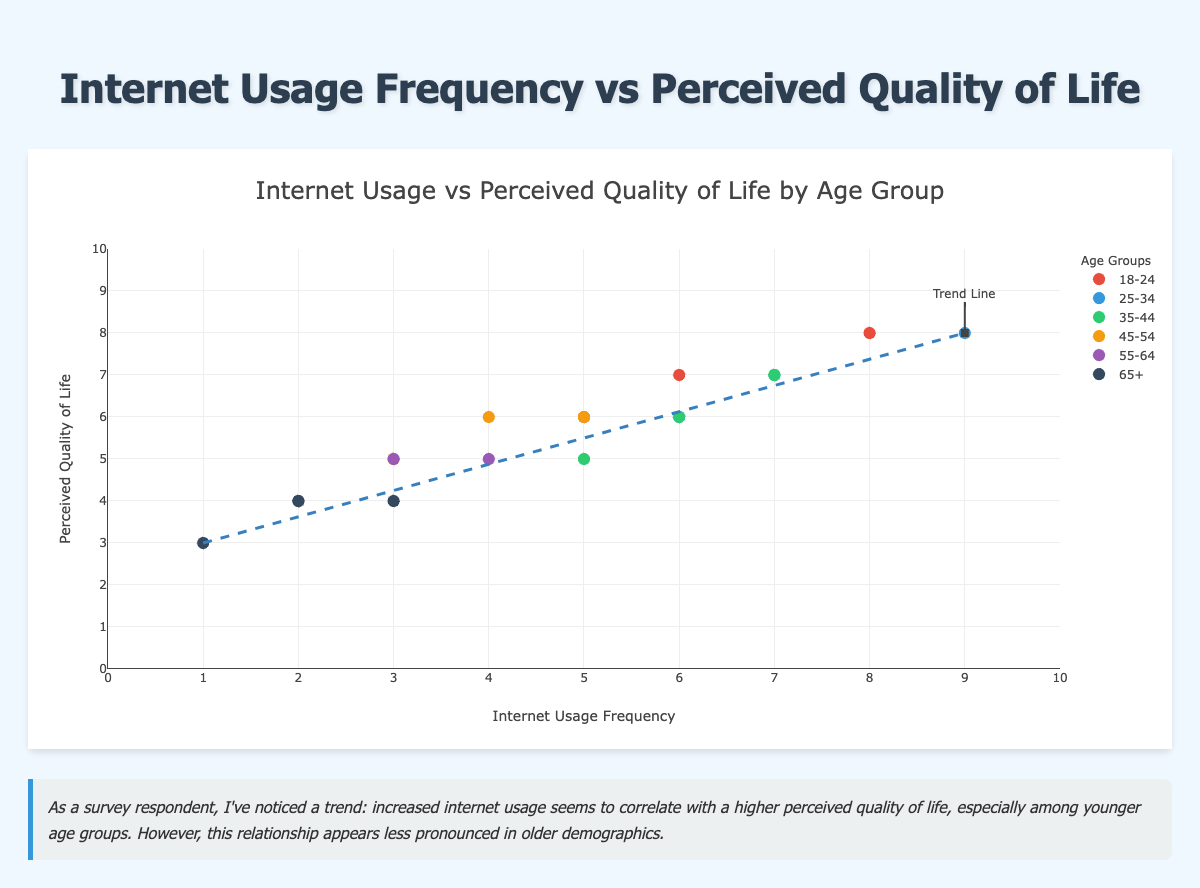What is the title of the scatter plot? The title is found at the top of the scatter plot. It is "Internet Usage Frequency vs Perceived Quality of Life by Age Group".
Answer: Internet Usage Frequency vs Perceived Quality of Life by Age Group What are the axis labels for the scatter plot? The x-axis label is "Internet Usage Frequency", and the y-axis label is "Perceived Quality of Life". These labels are located along the respective axes.
Answer: Internet Usage Frequency (x-axis), Perceived Quality of Life (y-axis) Which age group has the highest perceived quality of life? Looking at the highest data points on the y-axis and referring to the legend for age group color codes, the age group "18-24" reaches a perceived quality of life of 8.
Answer: 18-24 What pattern can be observed in the trend line? The trend line starts at a low value (internet usage frequency of 1, quality of life of 3) and increases to higher values, suggesting a positive correlation between internet usage frequency and perceived quality of life.
Answer: Positive correlation How does the perceived quality of life change with internet usage frequency for the 65+ age group? For the "65+" age group, observing points with different colors indicating 65+ shows there is little variation in quality of life with different usage frequencies, generally between 3 and 4.
Answer: Little variation, generally between 3 and 4 What is the range of internet usage frequency for the 25-34 age group? By checking the markers linked to the age group "25-34" and observing their positions along the x-axis, the usage frequency ranges from 6 to 9.
Answer: 6 to 9 Compare the perceived quality of life between the younger (18-24) and older (65+) age groups. The younger age group (18-24) has a perceived quality of life ranging from 6 to 8, while the older age group (65+) has a lower range from 3 to 4, indicating that younger participants report higher quality of life.
Answer: 18-24: 6-8, 65+: 3-4 What does the shape annotated as the "Trend Line" indicate? The trend line indicates the general direction of the relationship between internet usage frequency and perceived quality of life, showing an upward slope which signifies a positive correlation.
Answer: Positive correlation 